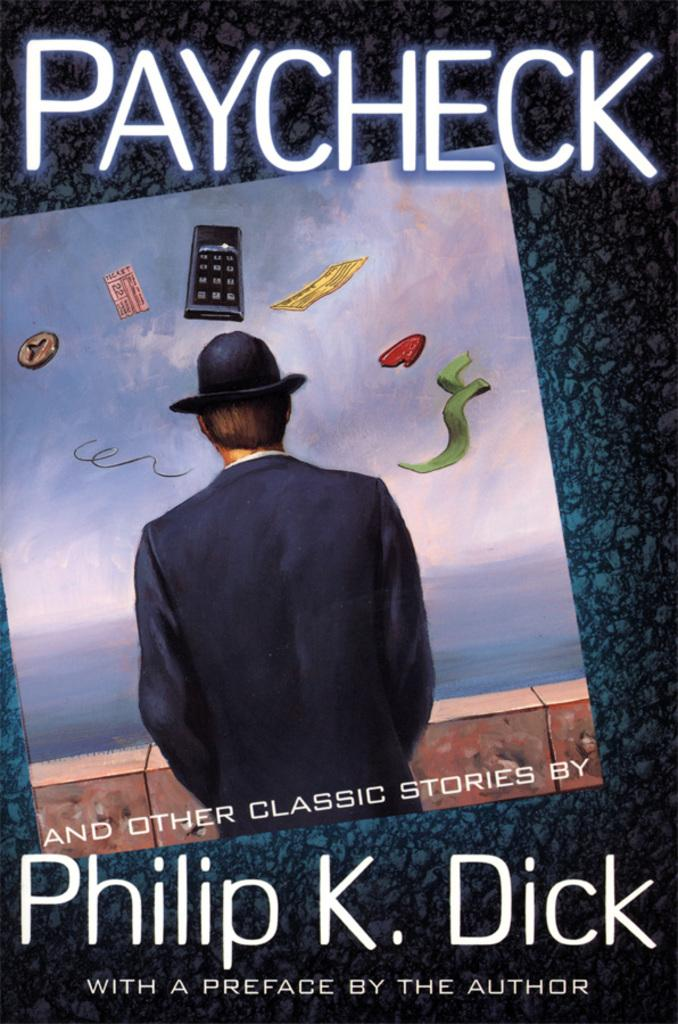<image>
Present a compact description of the photo's key features. Book called paycheck from Philip K Dick the author 